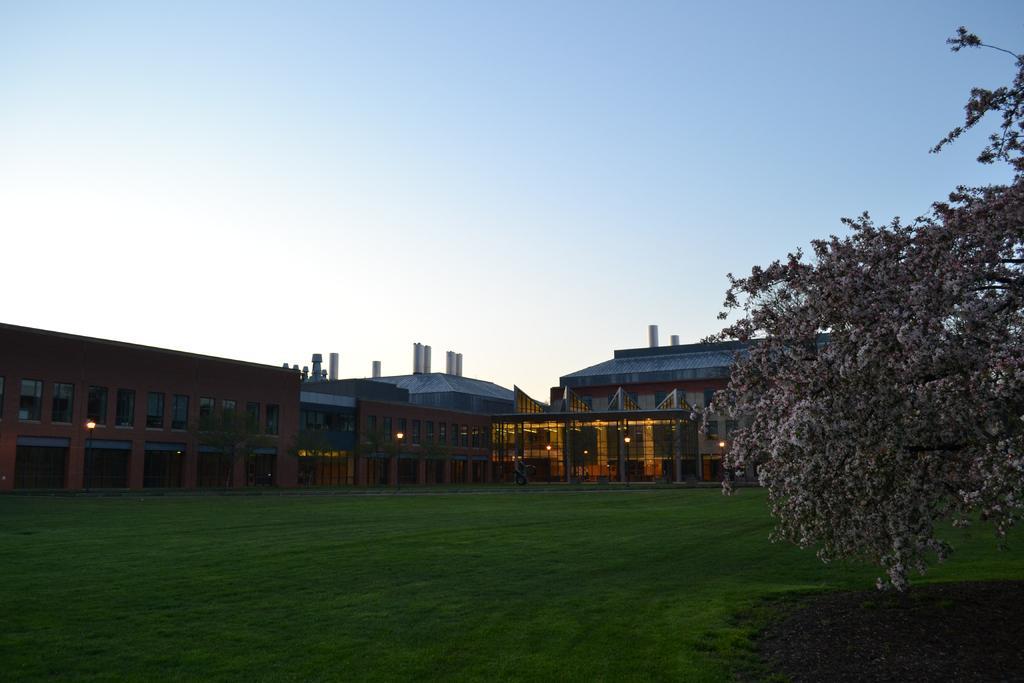Can you describe this image briefly? On the right there is a tree. In the foreground there is grass. In the middle of the picture there are buildings. At the top there is sky. 